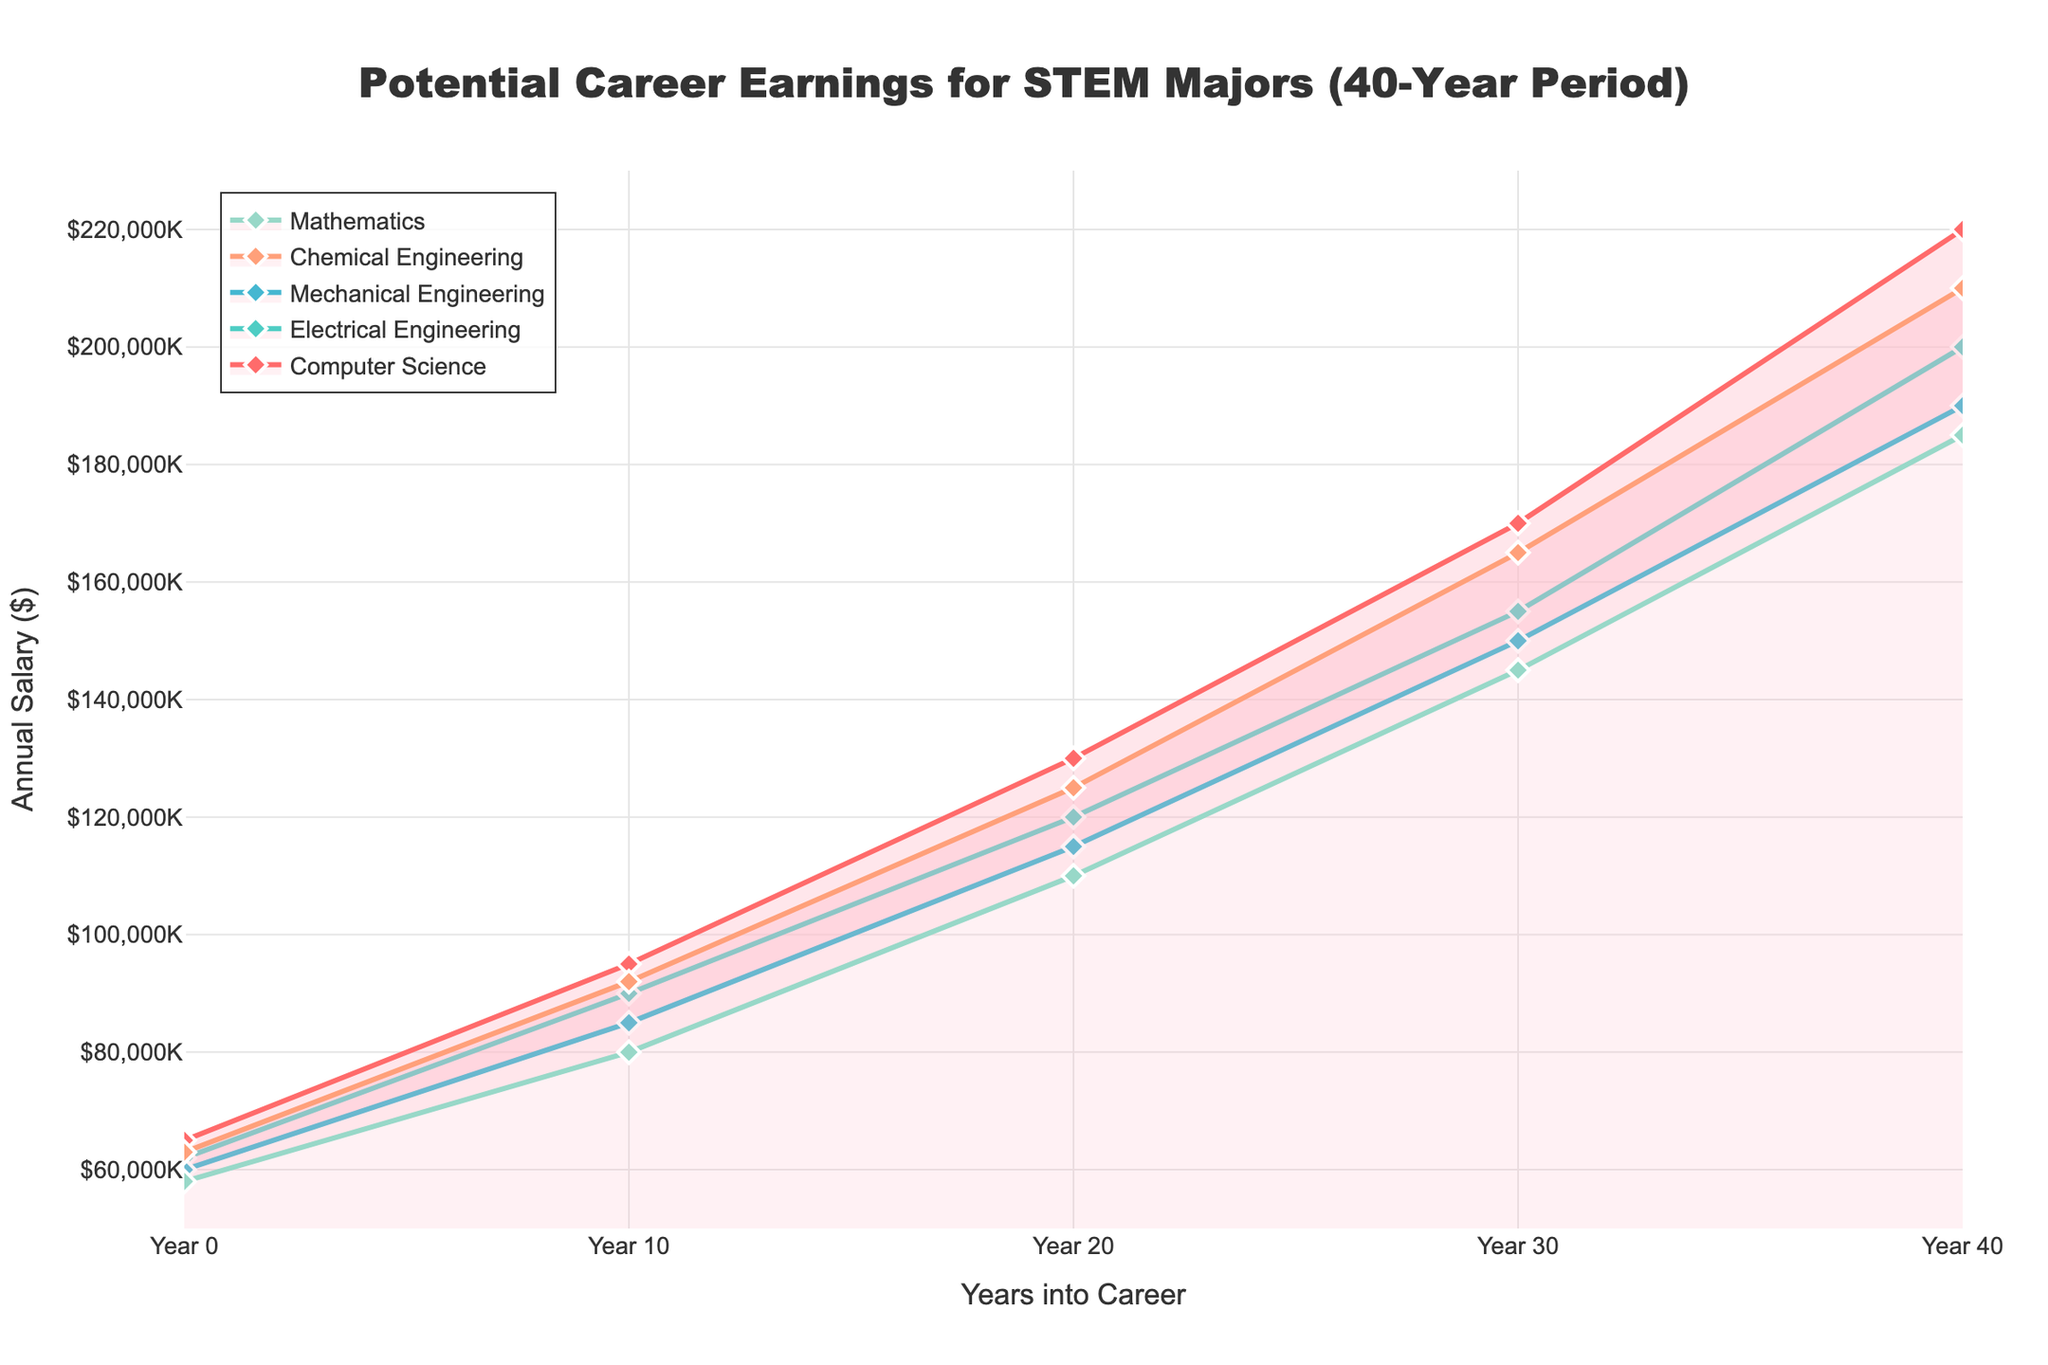What is the title of the figure? The title of the figure is written at the top and should be easily readable.
Answer: Potential Career Earnings for STEM Majors (40-Year Period) How many years does the chart cover? The x-axis shows the time period in years, and it ranges from 0 to 40.
Answer: 40 years Which major starts with the highest salary at year 0? Look at the data points at year 0 on the x-axis and identify which major has the highest y-value.
Answer: Computer Science How much does the salary for Chemical Engineering increase from year 10 to year 20? Check the y-values for Chemical Engineering at year 10 and year 20, then find the difference: $125,000 - $92,000.
Answer: $33,000 At year 30, which major has higher earnings, Mathematics or Electrical Engineering? Compare the y-values for Mathematics and Electrical Engineering at year 30.
Answer: Electrical Engineering Which major shows the greatest total increase in salary from year 0 to year 40? Calculate the difference between the salaries at year 40 and year 0 for each major, and identify the highest value.
Answer: Computer Science What is the average salary for Mechanical Engineering over the 40-year period? Calculate the mean of the y-values for Mechanical Engineering: (60000 + 85000 + 115000 + 150000 + 190000) / 5.
Answer: $120,000 How does the salary trend for Mathematics compare to that for Chemical Engineering? Observe the slope of the lines for Mathematics and Chemical Engineering. Mathematics shows a steady increase, whereas Chemical Engineering shows a faster initial increase but then a similar trend.
Answer: Similar overall trend but Chemistry with a faster initial increase What is the predicted salary for Electrical Engineering at year 20? Locate the y-value for Electrical Engineering at year 20 on the graph.
Answer: $120,000 